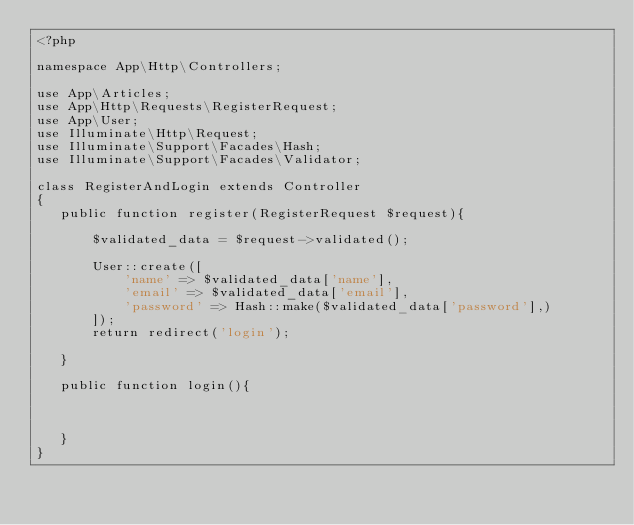<code> <loc_0><loc_0><loc_500><loc_500><_PHP_><?php

namespace App\Http\Controllers;

use App\Articles;
use App\Http\Requests\RegisterRequest;
use App\User;
use Illuminate\Http\Request;
use Illuminate\Support\Facades\Hash;
use Illuminate\Support\Facades\Validator;

class RegisterAndLogin extends Controller
{
   public function register(RegisterRequest $request){

       $validated_data = $request->validated();

       User::create([
           'name' => $validated_data['name'],
           'email' => $validated_data['email'],
           'password' => Hash::make($validated_data['password'],)
       ]);
       return redirect('login');

   }

   public function login(){



   }
}
</code> 